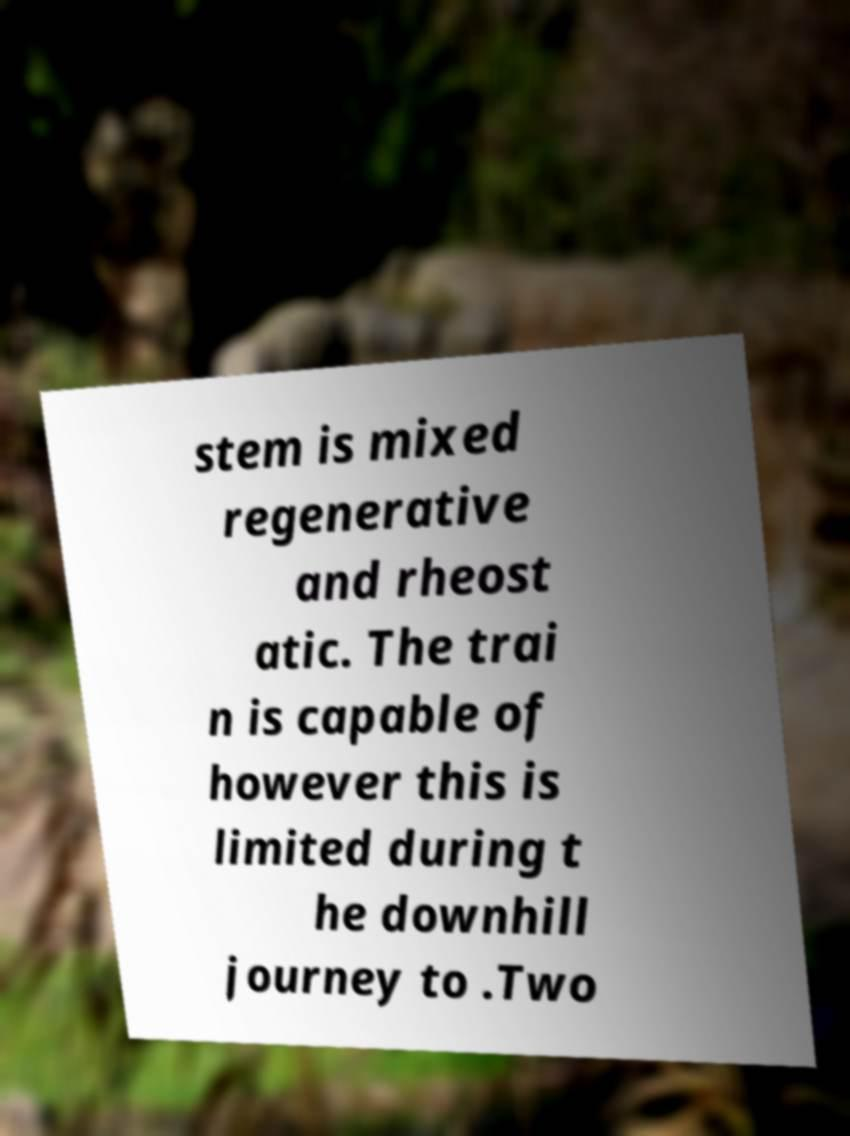Please read and relay the text visible in this image. What does it say? stem is mixed regenerative and rheost atic. The trai n is capable of however this is limited during t he downhill journey to .Two 